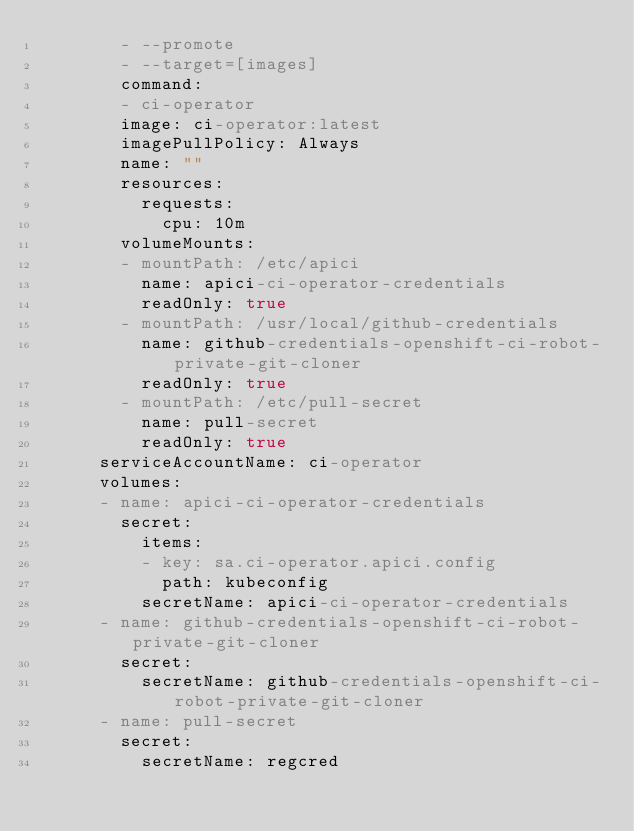<code> <loc_0><loc_0><loc_500><loc_500><_YAML_>        - --promote
        - --target=[images]
        command:
        - ci-operator
        image: ci-operator:latest
        imagePullPolicy: Always
        name: ""
        resources:
          requests:
            cpu: 10m
        volumeMounts:
        - mountPath: /etc/apici
          name: apici-ci-operator-credentials
          readOnly: true
        - mountPath: /usr/local/github-credentials
          name: github-credentials-openshift-ci-robot-private-git-cloner
          readOnly: true
        - mountPath: /etc/pull-secret
          name: pull-secret
          readOnly: true
      serviceAccountName: ci-operator
      volumes:
      - name: apici-ci-operator-credentials
        secret:
          items:
          - key: sa.ci-operator.apici.config
            path: kubeconfig
          secretName: apici-ci-operator-credentials
      - name: github-credentials-openshift-ci-robot-private-git-cloner
        secret:
          secretName: github-credentials-openshift-ci-robot-private-git-cloner
      - name: pull-secret
        secret:
          secretName: regcred
</code> 